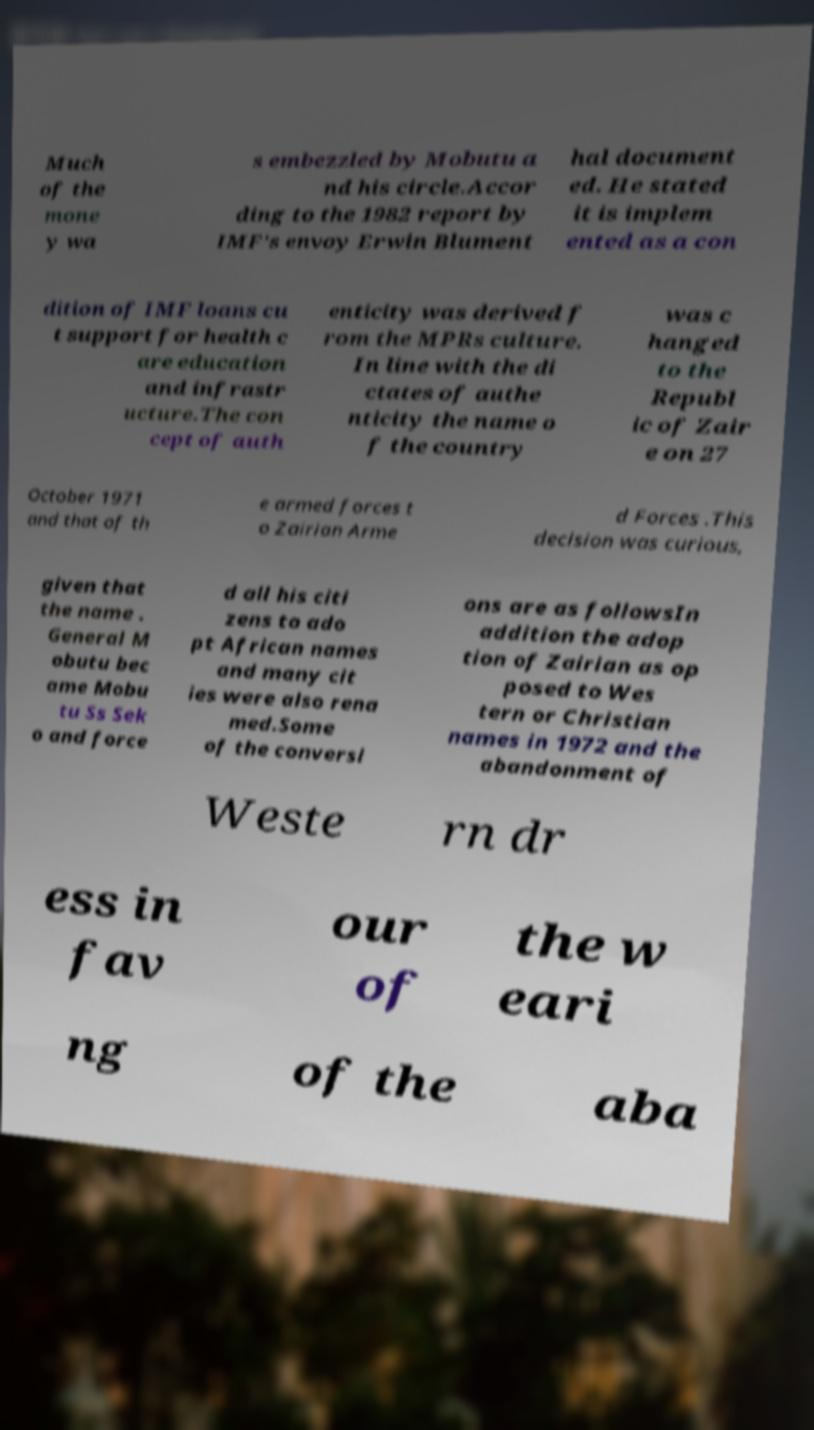Please read and relay the text visible in this image. What does it say? Much of the mone y wa s embezzled by Mobutu a nd his circle.Accor ding to the 1982 report by IMF's envoy Erwin Blument hal document ed. He stated it is implem ented as a con dition of IMF loans cu t support for health c are education and infrastr ucture.The con cept of auth enticity was derived f rom the MPRs culture. In line with the di ctates of authe nticity the name o f the country was c hanged to the Republ ic of Zair e on 27 October 1971 and that of th e armed forces t o Zairian Arme d Forces .This decision was curious, given that the name . General M obutu bec ame Mobu tu Ss Sek o and force d all his citi zens to ado pt African names and many cit ies were also rena med.Some of the conversi ons are as followsIn addition the adop tion of Zairian as op posed to Wes tern or Christian names in 1972 and the abandonment of  Weste rn dr ess in fav our of the w eari ng of the aba 